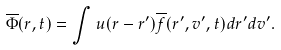<formula> <loc_0><loc_0><loc_500><loc_500>\overline { \Phi } ( { r } , t ) = \int u ( { r } - { r } ^ { \prime } ) \overline { f } ( { r } ^ { \prime } , { v } ^ { \prime } , t ) d { r } ^ { \prime } d { v } ^ { \prime } .</formula> 